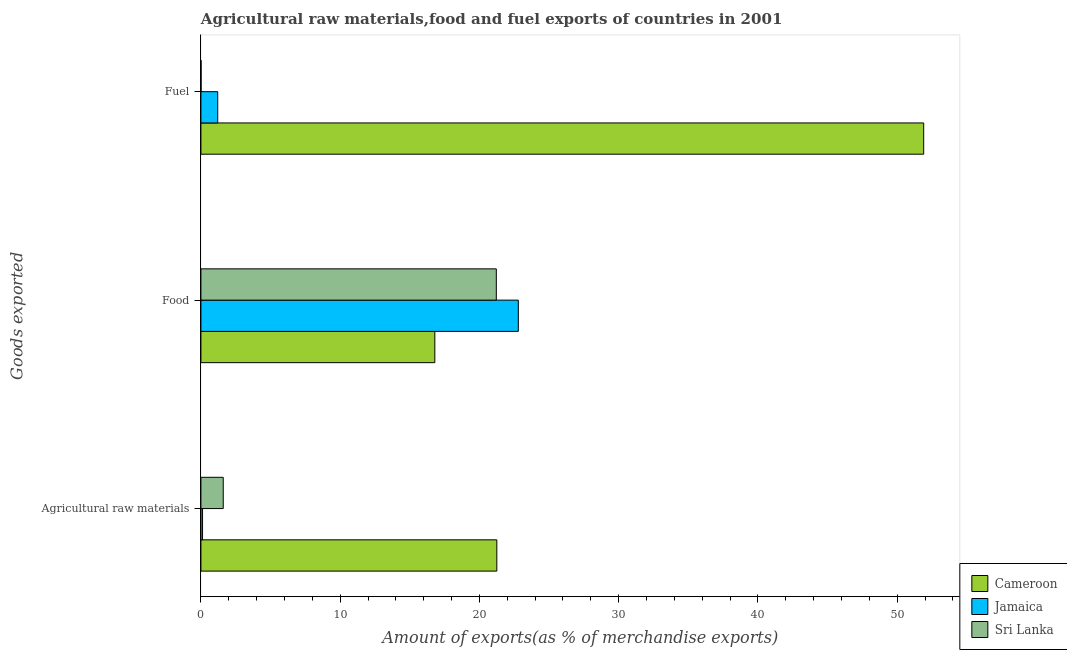How many groups of bars are there?
Your response must be concise. 3. Are the number of bars per tick equal to the number of legend labels?
Keep it short and to the point. Yes. How many bars are there on the 2nd tick from the top?
Give a very brief answer. 3. How many bars are there on the 3rd tick from the bottom?
Ensure brevity in your answer.  3. What is the label of the 3rd group of bars from the top?
Your answer should be compact. Agricultural raw materials. What is the percentage of food exports in Jamaica?
Ensure brevity in your answer.  22.79. Across all countries, what is the maximum percentage of raw materials exports?
Your answer should be compact. 21.25. Across all countries, what is the minimum percentage of food exports?
Your answer should be compact. 16.8. In which country was the percentage of fuel exports maximum?
Your answer should be very brief. Cameroon. In which country was the percentage of fuel exports minimum?
Offer a very short reply. Sri Lanka. What is the total percentage of food exports in the graph?
Your answer should be very brief. 60.8. What is the difference between the percentage of fuel exports in Sri Lanka and that in Jamaica?
Make the answer very short. -1.2. What is the difference between the percentage of raw materials exports in Cameroon and the percentage of fuel exports in Jamaica?
Ensure brevity in your answer.  20.04. What is the average percentage of raw materials exports per country?
Offer a very short reply. 7.66. What is the difference between the percentage of raw materials exports and percentage of fuel exports in Sri Lanka?
Your answer should be very brief. 1.59. In how many countries, is the percentage of fuel exports greater than 6 %?
Your answer should be compact. 1. What is the ratio of the percentage of raw materials exports in Sri Lanka to that in Jamaica?
Your answer should be very brief. 13.64. What is the difference between the highest and the second highest percentage of food exports?
Make the answer very short. 1.58. What is the difference between the highest and the lowest percentage of food exports?
Ensure brevity in your answer.  6. In how many countries, is the percentage of fuel exports greater than the average percentage of fuel exports taken over all countries?
Provide a succinct answer. 1. What does the 1st bar from the top in Fuel represents?
Provide a succinct answer. Sri Lanka. What does the 2nd bar from the bottom in Fuel represents?
Offer a very short reply. Jamaica. How many bars are there?
Your response must be concise. 9. Does the graph contain any zero values?
Offer a very short reply. No. How many legend labels are there?
Keep it short and to the point. 3. What is the title of the graph?
Your response must be concise. Agricultural raw materials,food and fuel exports of countries in 2001. Does "Mali" appear as one of the legend labels in the graph?
Your response must be concise. No. What is the label or title of the X-axis?
Your answer should be very brief. Amount of exports(as % of merchandise exports). What is the label or title of the Y-axis?
Offer a terse response. Goods exported. What is the Amount of exports(as % of merchandise exports) in Cameroon in Agricultural raw materials?
Offer a very short reply. 21.25. What is the Amount of exports(as % of merchandise exports) in Jamaica in Agricultural raw materials?
Keep it short and to the point. 0.12. What is the Amount of exports(as % of merchandise exports) in Sri Lanka in Agricultural raw materials?
Offer a very short reply. 1.6. What is the Amount of exports(as % of merchandise exports) in Cameroon in Food?
Make the answer very short. 16.8. What is the Amount of exports(as % of merchandise exports) in Jamaica in Food?
Ensure brevity in your answer.  22.79. What is the Amount of exports(as % of merchandise exports) of Sri Lanka in Food?
Offer a terse response. 21.21. What is the Amount of exports(as % of merchandise exports) of Cameroon in Fuel?
Provide a short and direct response. 51.9. What is the Amount of exports(as % of merchandise exports) in Jamaica in Fuel?
Give a very brief answer. 1.21. What is the Amount of exports(as % of merchandise exports) in Sri Lanka in Fuel?
Your response must be concise. 0.01. Across all Goods exported, what is the maximum Amount of exports(as % of merchandise exports) in Cameroon?
Keep it short and to the point. 51.9. Across all Goods exported, what is the maximum Amount of exports(as % of merchandise exports) in Jamaica?
Your response must be concise. 22.79. Across all Goods exported, what is the maximum Amount of exports(as % of merchandise exports) of Sri Lanka?
Offer a terse response. 21.21. Across all Goods exported, what is the minimum Amount of exports(as % of merchandise exports) in Cameroon?
Keep it short and to the point. 16.8. Across all Goods exported, what is the minimum Amount of exports(as % of merchandise exports) of Jamaica?
Your answer should be very brief. 0.12. Across all Goods exported, what is the minimum Amount of exports(as % of merchandise exports) in Sri Lanka?
Give a very brief answer. 0.01. What is the total Amount of exports(as % of merchandise exports) of Cameroon in the graph?
Provide a succinct answer. 89.95. What is the total Amount of exports(as % of merchandise exports) in Jamaica in the graph?
Make the answer very short. 24.12. What is the total Amount of exports(as % of merchandise exports) of Sri Lanka in the graph?
Offer a terse response. 22.83. What is the difference between the Amount of exports(as % of merchandise exports) in Cameroon in Agricultural raw materials and that in Food?
Offer a terse response. 4.45. What is the difference between the Amount of exports(as % of merchandise exports) in Jamaica in Agricultural raw materials and that in Food?
Make the answer very short. -22.68. What is the difference between the Amount of exports(as % of merchandise exports) in Sri Lanka in Agricultural raw materials and that in Food?
Make the answer very short. -19.61. What is the difference between the Amount of exports(as % of merchandise exports) in Cameroon in Agricultural raw materials and that in Fuel?
Make the answer very short. -30.65. What is the difference between the Amount of exports(as % of merchandise exports) in Jamaica in Agricultural raw materials and that in Fuel?
Your answer should be very brief. -1.09. What is the difference between the Amount of exports(as % of merchandise exports) in Sri Lanka in Agricultural raw materials and that in Fuel?
Give a very brief answer. 1.59. What is the difference between the Amount of exports(as % of merchandise exports) in Cameroon in Food and that in Fuel?
Make the answer very short. -35.11. What is the difference between the Amount of exports(as % of merchandise exports) of Jamaica in Food and that in Fuel?
Your answer should be compact. 21.59. What is the difference between the Amount of exports(as % of merchandise exports) in Sri Lanka in Food and that in Fuel?
Give a very brief answer. 21.2. What is the difference between the Amount of exports(as % of merchandise exports) of Cameroon in Agricultural raw materials and the Amount of exports(as % of merchandise exports) of Jamaica in Food?
Your answer should be very brief. -1.54. What is the difference between the Amount of exports(as % of merchandise exports) of Cameroon in Agricultural raw materials and the Amount of exports(as % of merchandise exports) of Sri Lanka in Food?
Offer a very short reply. 0.04. What is the difference between the Amount of exports(as % of merchandise exports) of Jamaica in Agricultural raw materials and the Amount of exports(as % of merchandise exports) of Sri Lanka in Food?
Ensure brevity in your answer.  -21.1. What is the difference between the Amount of exports(as % of merchandise exports) of Cameroon in Agricultural raw materials and the Amount of exports(as % of merchandise exports) of Jamaica in Fuel?
Provide a succinct answer. 20.04. What is the difference between the Amount of exports(as % of merchandise exports) in Cameroon in Agricultural raw materials and the Amount of exports(as % of merchandise exports) in Sri Lanka in Fuel?
Provide a succinct answer. 21.24. What is the difference between the Amount of exports(as % of merchandise exports) of Jamaica in Agricultural raw materials and the Amount of exports(as % of merchandise exports) of Sri Lanka in Fuel?
Your answer should be compact. 0.11. What is the difference between the Amount of exports(as % of merchandise exports) in Cameroon in Food and the Amount of exports(as % of merchandise exports) in Jamaica in Fuel?
Offer a very short reply. 15.59. What is the difference between the Amount of exports(as % of merchandise exports) of Cameroon in Food and the Amount of exports(as % of merchandise exports) of Sri Lanka in Fuel?
Make the answer very short. 16.79. What is the difference between the Amount of exports(as % of merchandise exports) in Jamaica in Food and the Amount of exports(as % of merchandise exports) in Sri Lanka in Fuel?
Your answer should be very brief. 22.78. What is the average Amount of exports(as % of merchandise exports) of Cameroon per Goods exported?
Your answer should be very brief. 29.98. What is the average Amount of exports(as % of merchandise exports) of Jamaica per Goods exported?
Your answer should be compact. 8.04. What is the average Amount of exports(as % of merchandise exports) of Sri Lanka per Goods exported?
Keep it short and to the point. 7.61. What is the difference between the Amount of exports(as % of merchandise exports) of Cameroon and Amount of exports(as % of merchandise exports) of Jamaica in Agricultural raw materials?
Offer a very short reply. 21.13. What is the difference between the Amount of exports(as % of merchandise exports) of Cameroon and Amount of exports(as % of merchandise exports) of Sri Lanka in Agricultural raw materials?
Offer a terse response. 19.65. What is the difference between the Amount of exports(as % of merchandise exports) in Jamaica and Amount of exports(as % of merchandise exports) in Sri Lanka in Agricultural raw materials?
Provide a succinct answer. -1.49. What is the difference between the Amount of exports(as % of merchandise exports) of Cameroon and Amount of exports(as % of merchandise exports) of Jamaica in Food?
Offer a very short reply. -6. What is the difference between the Amount of exports(as % of merchandise exports) in Cameroon and Amount of exports(as % of merchandise exports) in Sri Lanka in Food?
Your answer should be compact. -4.42. What is the difference between the Amount of exports(as % of merchandise exports) of Jamaica and Amount of exports(as % of merchandise exports) of Sri Lanka in Food?
Keep it short and to the point. 1.58. What is the difference between the Amount of exports(as % of merchandise exports) in Cameroon and Amount of exports(as % of merchandise exports) in Jamaica in Fuel?
Your answer should be very brief. 50.7. What is the difference between the Amount of exports(as % of merchandise exports) of Cameroon and Amount of exports(as % of merchandise exports) of Sri Lanka in Fuel?
Offer a very short reply. 51.89. What is the difference between the Amount of exports(as % of merchandise exports) in Jamaica and Amount of exports(as % of merchandise exports) in Sri Lanka in Fuel?
Provide a succinct answer. 1.2. What is the ratio of the Amount of exports(as % of merchandise exports) in Cameroon in Agricultural raw materials to that in Food?
Keep it short and to the point. 1.27. What is the ratio of the Amount of exports(as % of merchandise exports) in Jamaica in Agricultural raw materials to that in Food?
Your response must be concise. 0.01. What is the ratio of the Amount of exports(as % of merchandise exports) in Sri Lanka in Agricultural raw materials to that in Food?
Give a very brief answer. 0.08. What is the ratio of the Amount of exports(as % of merchandise exports) of Cameroon in Agricultural raw materials to that in Fuel?
Your answer should be very brief. 0.41. What is the ratio of the Amount of exports(as % of merchandise exports) in Jamaica in Agricultural raw materials to that in Fuel?
Make the answer very short. 0.1. What is the ratio of the Amount of exports(as % of merchandise exports) in Sri Lanka in Agricultural raw materials to that in Fuel?
Your answer should be compact. 142.19. What is the ratio of the Amount of exports(as % of merchandise exports) in Cameroon in Food to that in Fuel?
Give a very brief answer. 0.32. What is the ratio of the Amount of exports(as % of merchandise exports) of Jamaica in Food to that in Fuel?
Ensure brevity in your answer.  18.89. What is the ratio of the Amount of exports(as % of merchandise exports) of Sri Lanka in Food to that in Fuel?
Your response must be concise. 1882.3. What is the difference between the highest and the second highest Amount of exports(as % of merchandise exports) in Cameroon?
Ensure brevity in your answer.  30.65. What is the difference between the highest and the second highest Amount of exports(as % of merchandise exports) of Jamaica?
Offer a terse response. 21.59. What is the difference between the highest and the second highest Amount of exports(as % of merchandise exports) in Sri Lanka?
Offer a terse response. 19.61. What is the difference between the highest and the lowest Amount of exports(as % of merchandise exports) of Cameroon?
Your response must be concise. 35.11. What is the difference between the highest and the lowest Amount of exports(as % of merchandise exports) of Jamaica?
Offer a very short reply. 22.68. What is the difference between the highest and the lowest Amount of exports(as % of merchandise exports) in Sri Lanka?
Offer a very short reply. 21.2. 